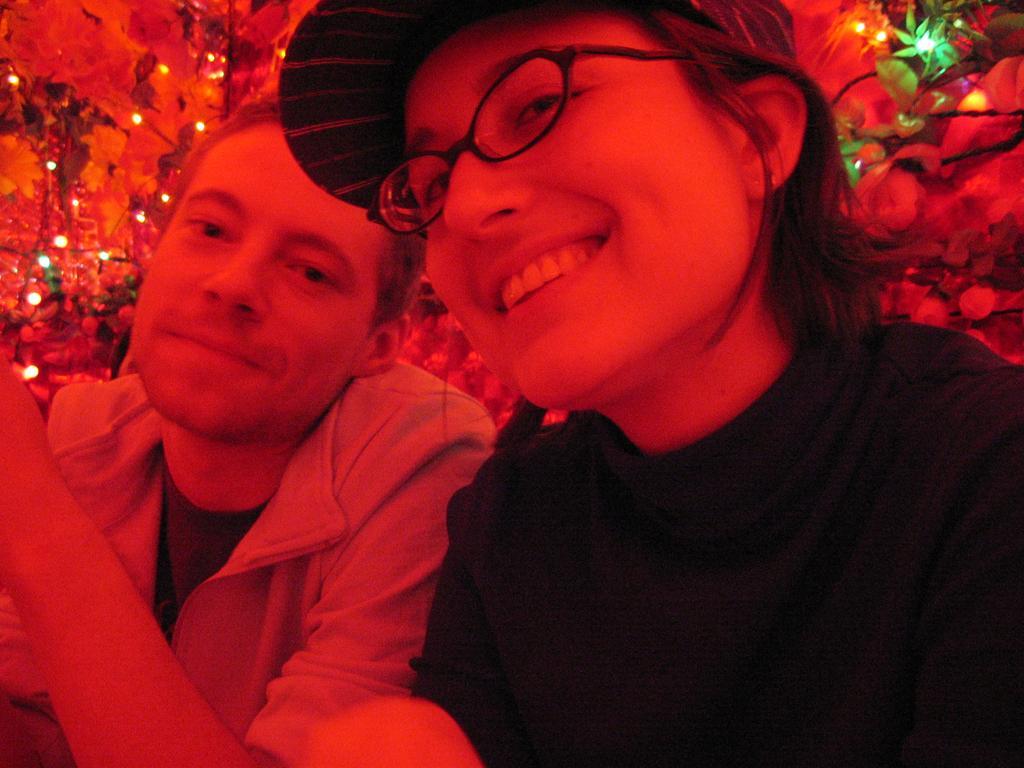Describe this image in one or two sentences. In this image there are two people. The person sitting on the right is wearing glasses and smiling, next to her there is a man. In the background there are decors and lights. 